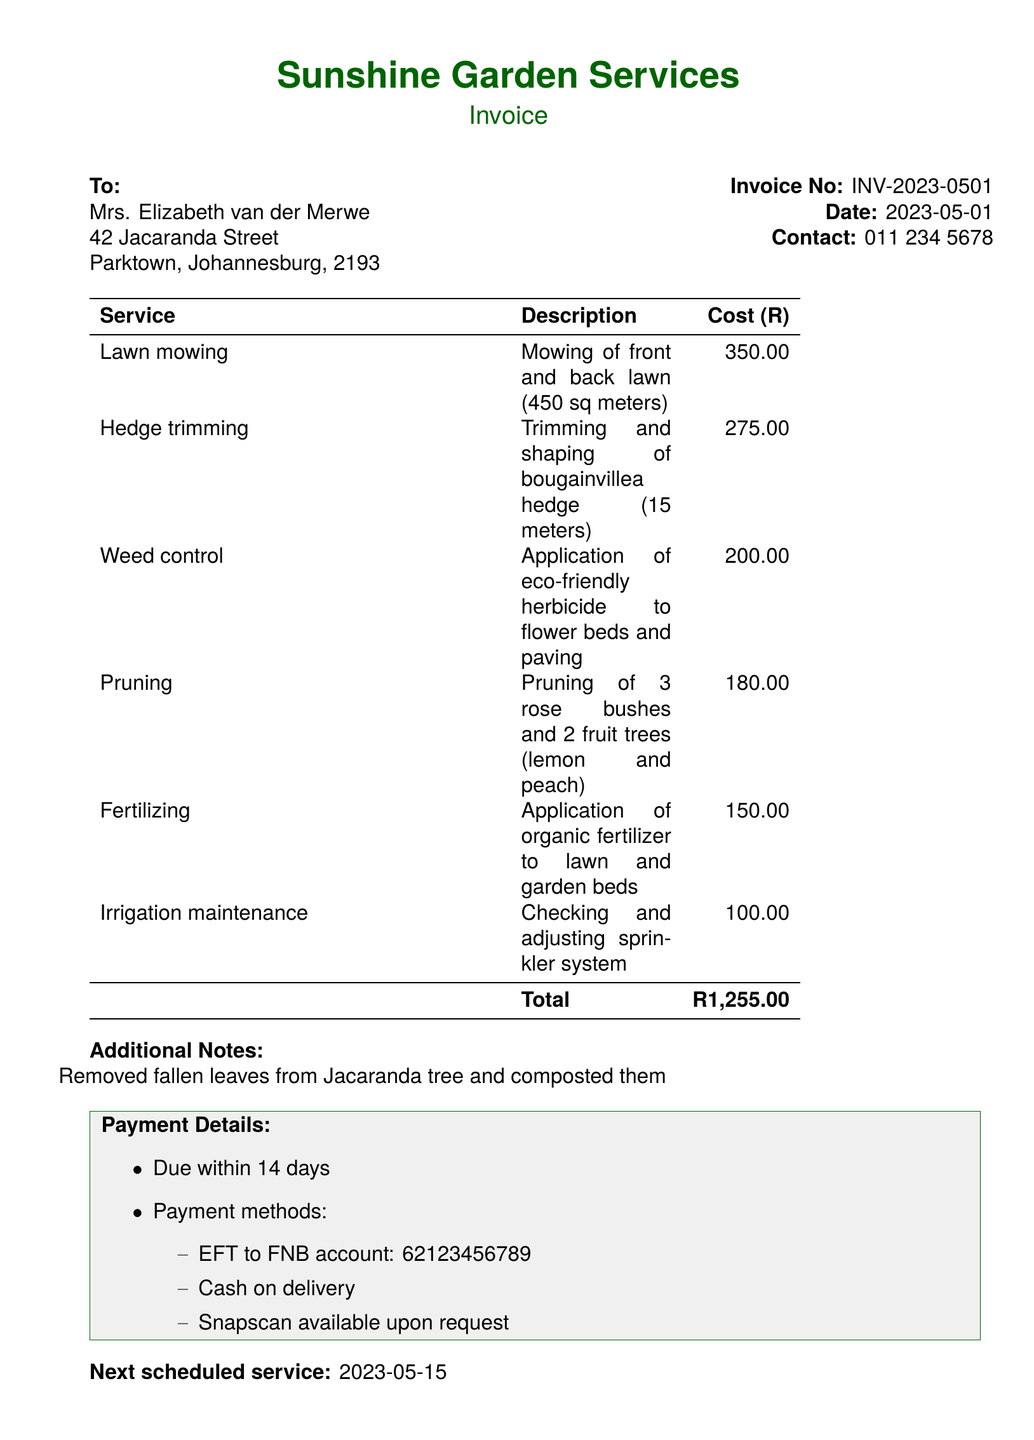What is the invoice number? The invoice number is a specific identifier for this transaction, found in the document.
Answer: INV-2023-0501 What is the total amount due? The total amount due is the cumulative cost of all services rendered as stated in the document.
Answer: R1,255.00 Who provides the gardening services? The name of the service provider is specified in the document.
Answer: Sunshine Garden Services When is the next scheduled service? The next scheduled service date is provided in the document for future reference.
Answer: 2023-05-15 What task involved applying a herbicide? This task is detailed in the services rendered section of the document.
Answer: Weed control Which method of payment is available upon request? This refers to a specific payment option mentioned in the payment methods section.
Answer: Snapscan What description is given for lawn mowing? The description provides information about the specific task performed, found in the services rendered section.
Answer: Mowing of front and back lawn (450 sq meters) How many rose bushes were pruned? This question asks for specific information found in the pruning task description.
Answer: 3 